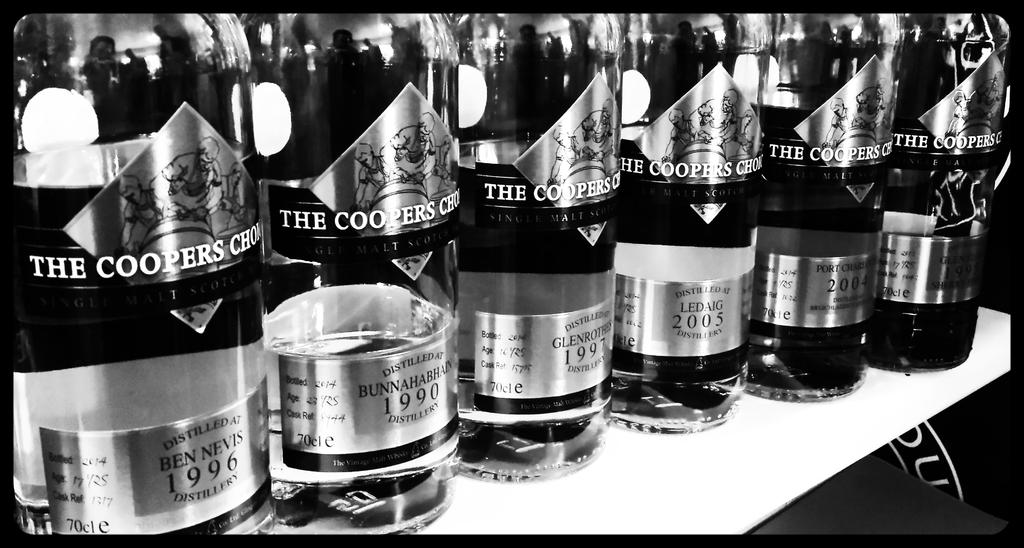What year was the first bottle on the left distilled?
Give a very brief answer. 1996. What is the firms name?
Your response must be concise. Unanswerable. 